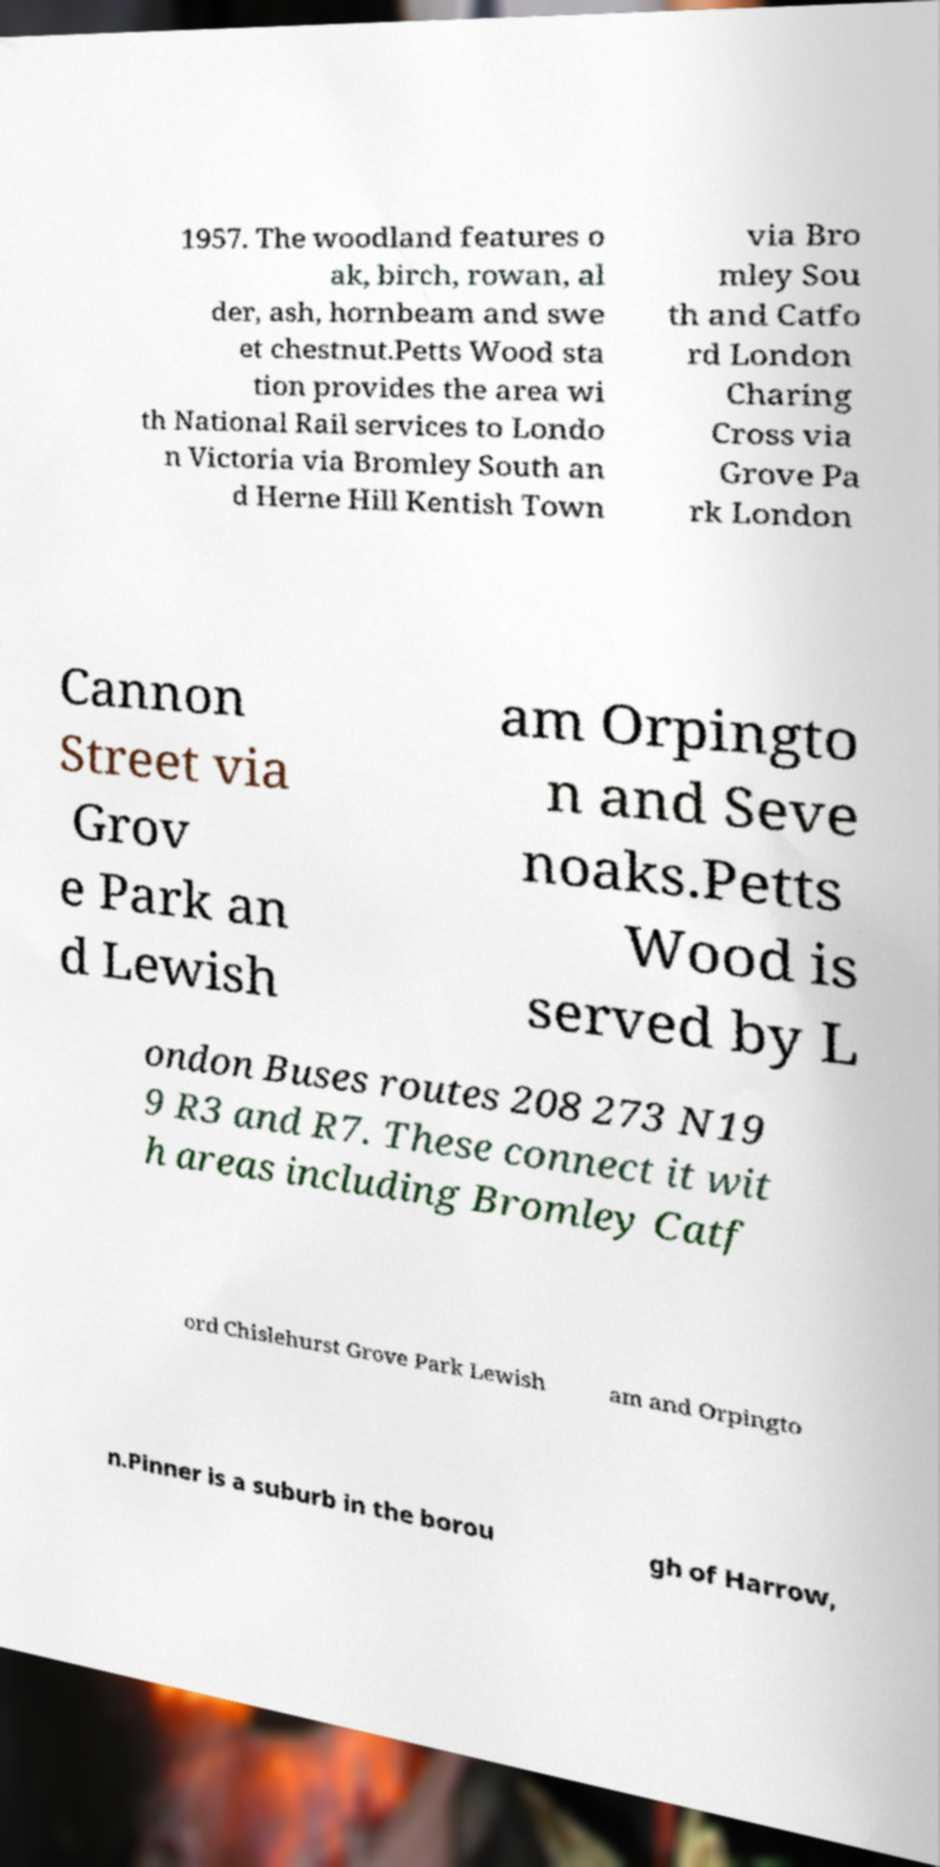Please identify and transcribe the text found in this image. 1957. The woodland features o ak, birch, rowan, al der, ash, hornbeam and swe et chestnut.Petts Wood sta tion provides the area wi th National Rail services to Londo n Victoria via Bromley South an d Herne Hill Kentish Town via Bro mley Sou th and Catfo rd London Charing Cross via Grove Pa rk London Cannon Street via Grov e Park an d Lewish am Orpingto n and Seve noaks.Petts Wood is served by L ondon Buses routes 208 273 N19 9 R3 and R7. These connect it wit h areas including Bromley Catf ord Chislehurst Grove Park Lewish am and Orpingto n.Pinner is a suburb in the borou gh of Harrow, 